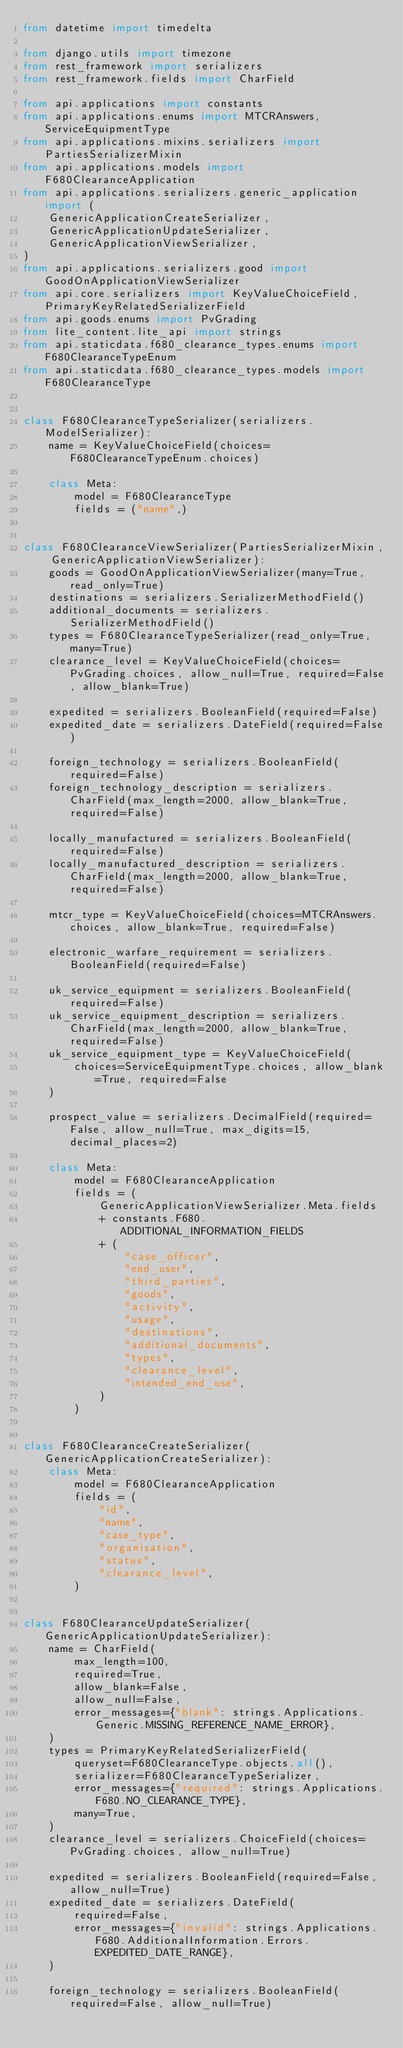<code> <loc_0><loc_0><loc_500><loc_500><_Python_>from datetime import timedelta

from django.utils import timezone
from rest_framework import serializers
from rest_framework.fields import CharField

from api.applications import constants
from api.applications.enums import MTCRAnswers, ServiceEquipmentType
from api.applications.mixins.serializers import PartiesSerializerMixin
from api.applications.models import F680ClearanceApplication
from api.applications.serializers.generic_application import (
    GenericApplicationCreateSerializer,
    GenericApplicationUpdateSerializer,
    GenericApplicationViewSerializer,
)
from api.applications.serializers.good import GoodOnApplicationViewSerializer
from api.core.serializers import KeyValueChoiceField, PrimaryKeyRelatedSerializerField
from api.goods.enums import PvGrading
from lite_content.lite_api import strings
from api.staticdata.f680_clearance_types.enums import F680ClearanceTypeEnum
from api.staticdata.f680_clearance_types.models import F680ClearanceType


class F680ClearanceTypeSerializer(serializers.ModelSerializer):
    name = KeyValueChoiceField(choices=F680ClearanceTypeEnum.choices)

    class Meta:
        model = F680ClearanceType
        fields = ("name",)


class F680ClearanceViewSerializer(PartiesSerializerMixin, GenericApplicationViewSerializer):
    goods = GoodOnApplicationViewSerializer(many=True, read_only=True)
    destinations = serializers.SerializerMethodField()
    additional_documents = serializers.SerializerMethodField()
    types = F680ClearanceTypeSerializer(read_only=True, many=True)
    clearance_level = KeyValueChoiceField(choices=PvGrading.choices, allow_null=True, required=False, allow_blank=True)

    expedited = serializers.BooleanField(required=False)
    expedited_date = serializers.DateField(required=False)

    foreign_technology = serializers.BooleanField(required=False)
    foreign_technology_description = serializers.CharField(max_length=2000, allow_blank=True, required=False)

    locally_manufactured = serializers.BooleanField(required=False)
    locally_manufactured_description = serializers.CharField(max_length=2000, allow_blank=True, required=False)

    mtcr_type = KeyValueChoiceField(choices=MTCRAnswers.choices, allow_blank=True, required=False)

    electronic_warfare_requirement = serializers.BooleanField(required=False)

    uk_service_equipment = serializers.BooleanField(required=False)
    uk_service_equipment_description = serializers.CharField(max_length=2000, allow_blank=True, required=False)
    uk_service_equipment_type = KeyValueChoiceField(
        choices=ServiceEquipmentType.choices, allow_blank=True, required=False
    )

    prospect_value = serializers.DecimalField(required=False, allow_null=True, max_digits=15, decimal_places=2)

    class Meta:
        model = F680ClearanceApplication
        fields = (
            GenericApplicationViewSerializer.Meta.fields
            + constants.F680.ADDITIONAL_INFORMATION_FIELDS
            + (
                "case_officer",
                "end_user",
                "third_parties",
                "goods",
                "activity",
                "usage",
                "destinations",
                "additional_documents",
                "types",
                "clearance_level",
                "intended_end_use",
            )
        )


class F680ClearanceCreateSerializer(GenericApplicationCreateSerializer):
    class Meta:
        model = F680ClearanceApplication
        fields = (
            "id",
            "name",
            "case_type",
            "organisation",
            "status",
            "clearance_level",
        )


class F680ClearanceUpdateSerializer(GenericApplicationUpdateSerializer):
    name = CharField(
        max_length=100,
        required=True,
        allow_blank=False,
        allow_null=False,
        error_messages={"blank": strings.Applications.Generic.MISSING_REFERENCE_NAME_ERROR},
    )
    types = PrimaryKeyRelatedSerializerField(
        queryset=F680ClearanceType.objects.all(),
        serializer=F680ClearanceTypeSerializer,
        error_messages={"required": strings.Applications.F680.NO_CLEARANCE_TYPE},
        many=True,
    )
    clearance_level = serializers.ChoiceField(choices=PvGrading.choices, allow_null=True)

    expedited = serializers.BooleanField(required=False, allow_null=True)
    expedited_date = serializers.DateField(
        required=False,
        error_messages={"invalid": strings.Applications.F680.AdditionalInformation.Errors.EXPEDITED_DATE_RANGE},
    )

    foreign_technology = serializers.BooleanField(required=False, allow_null=True)</code> 